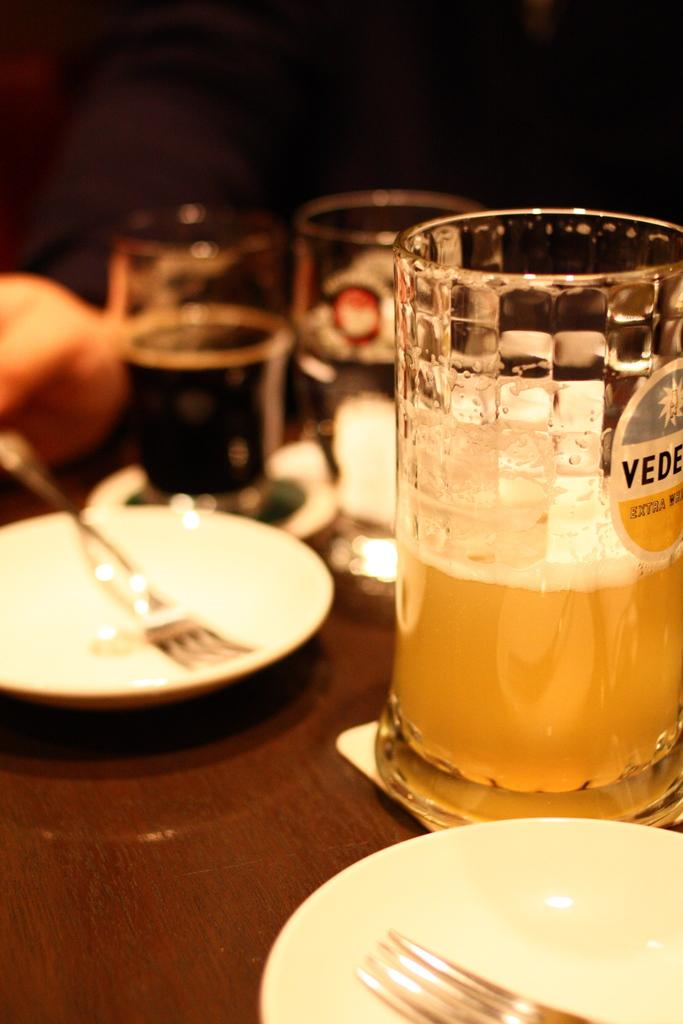What piece of furniture is present in the image? There is a table in the image. What objects are placed on the table? There are plates, forks, and glasses on the table. Can you describe any other items on the table? There are many other items on the table, but their specific details are not mentioned in the provided facts. What type of zinc is present on the table in the image? There is no mention of zinc in the image, so it cannot be determined if any zinc is present. How does the disgust factor of the image affect the viewer? The image does not convey any sense of disgust, so it cannot be determined how it would affect the viewer. 